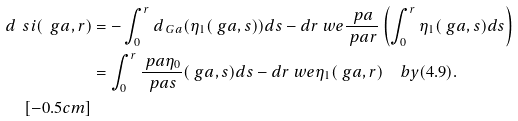Convert formula to latex. <formula><loc_0><loc_0><loc_500><loc_500>d \ s i ( \ g a , r ) & = - \int _ { 0 } ^ { r } d _ { \ G a } ( \eta _ { 1 } ( \ g a , s ) ) d s - d r \ w e \frac { \ p a } { \ p a r } \left ( \int _ { 0 } ^ { r } \eta _ { 1 } ( \ g a , s ) d s \right ) \\ & = \int _ { 0 } ^ { r } \frac { \ p a \eta _ { 0 } } { \ p a s } ( \ g a , s ) d s - d r \ w e \eta _ { 1 } ( \ g a , r ) \quad b y ( 4 . 9 ) . \\ [ - 0 . 5 c m ]</formula> 